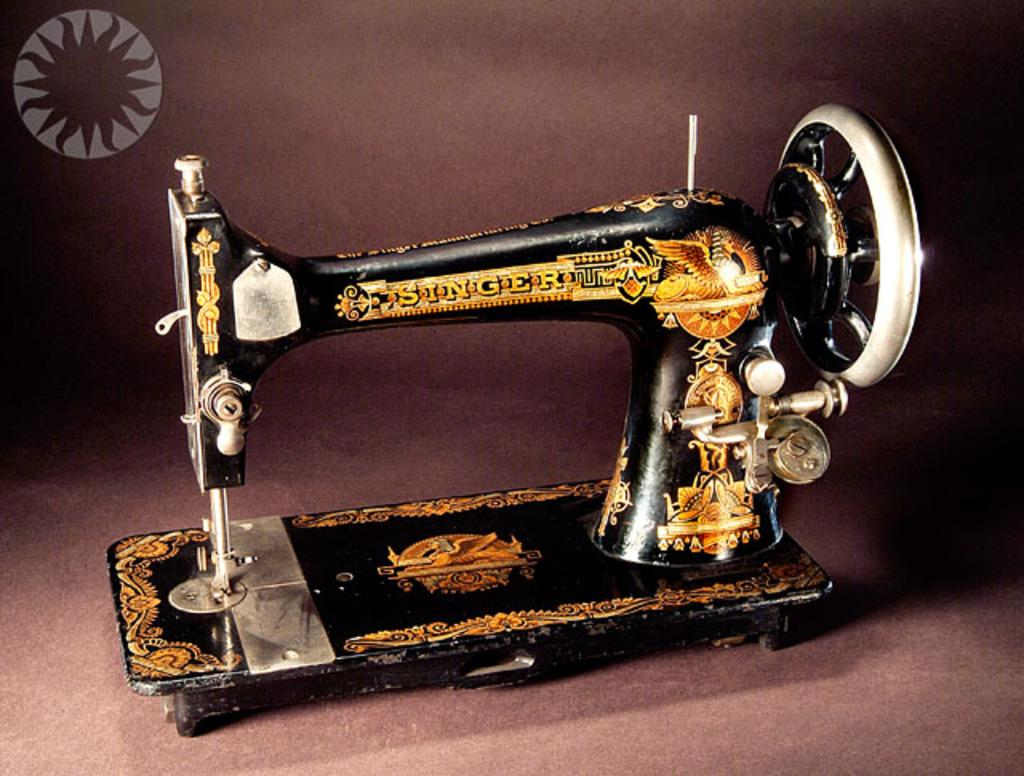What is the main object in the image? There is a sewing machine in the image. What colors are used for the sewing machine? The sewing machine is black and gold in color. What can be seen in the background of the image? The background of the image is brown. How many slices of pie are on the sewing machine in the image? There is no pie present in the image, so it is not possible to determine the number of slices. 